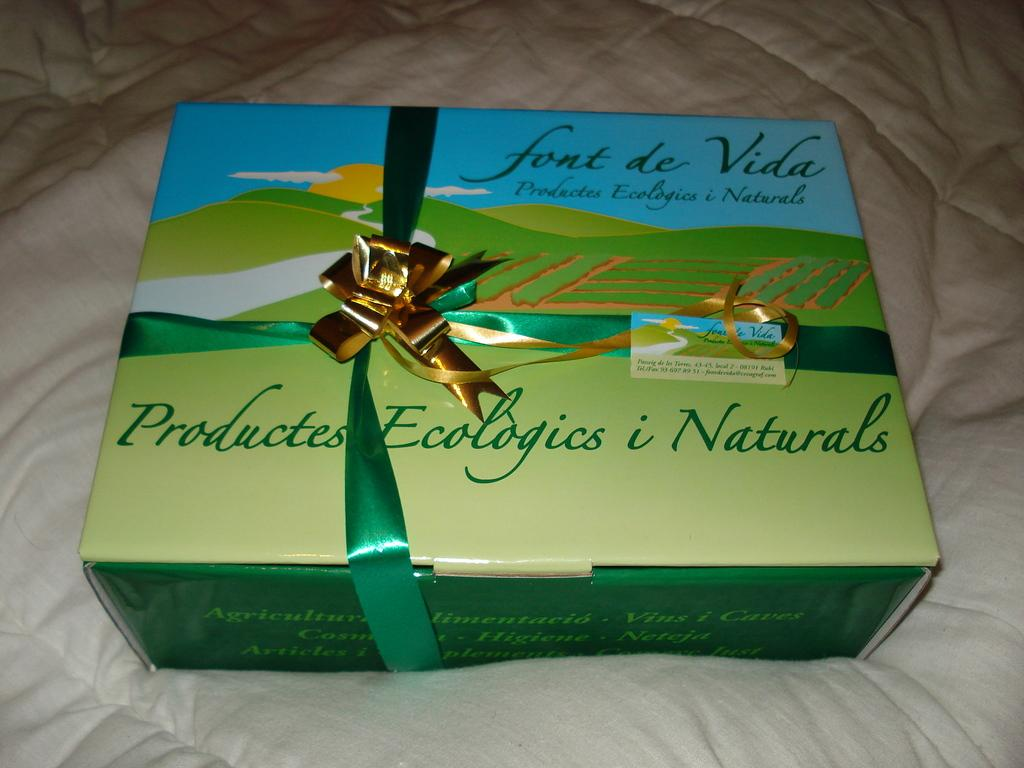<image>
Create a compact narrative representing the image presented. A wrapped gift box of Productes Ecologics i Naturals. 